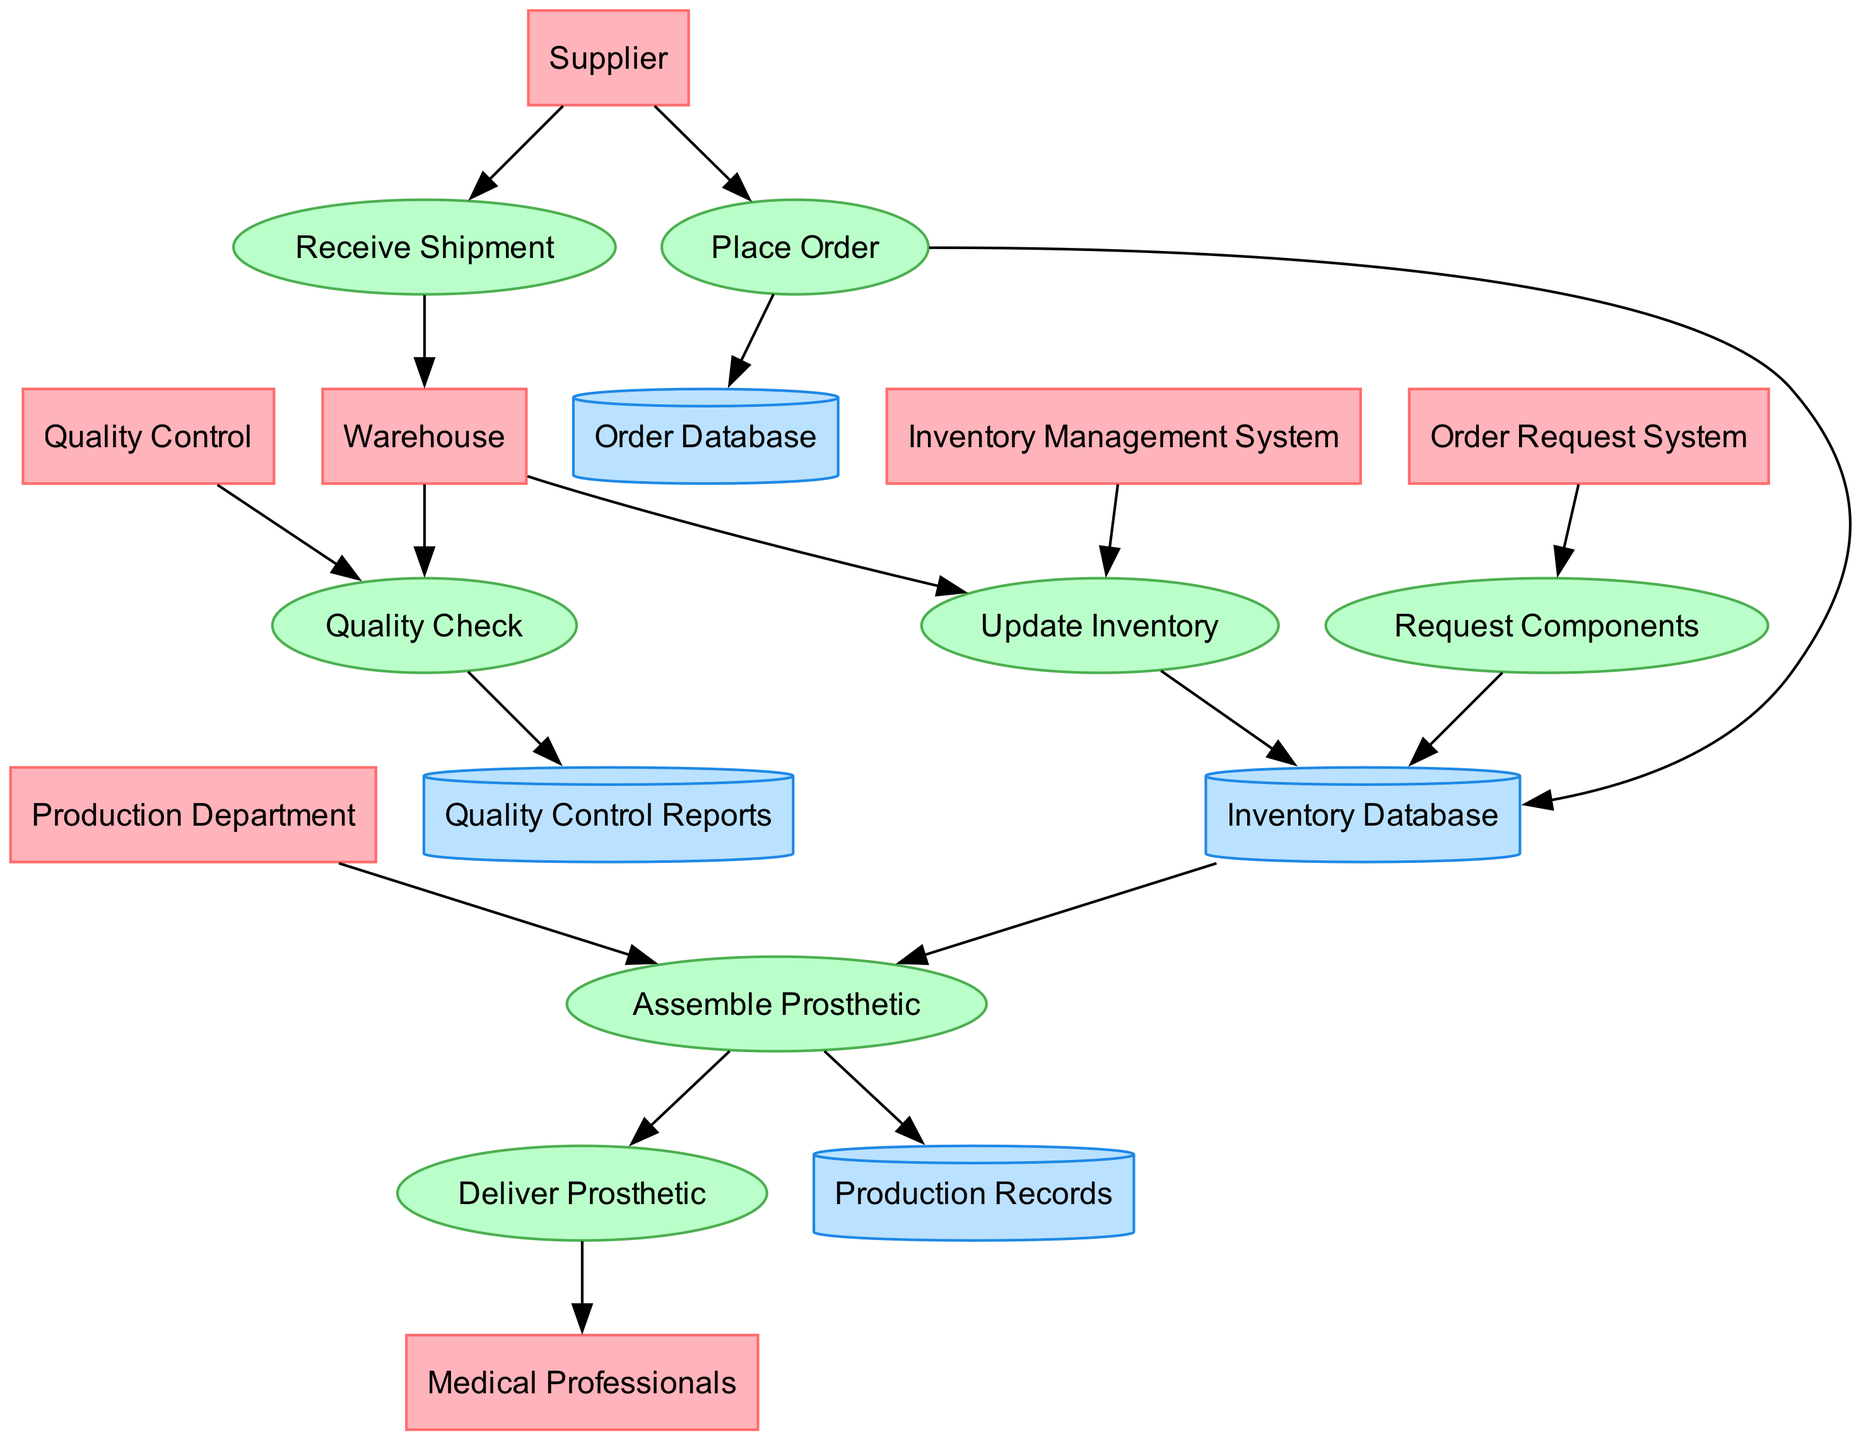What is the initial step in the inventory management process? The diagram shows that the initial step is 'Place Order', which is the process initiated in the Inventory Management System to request components from the Supplier.
Answer: Place Order Which department checks the quality of the components? The diagram indicates that the 'Quality Control' department is responsible for inspecting and verifying the components before they can be stored or used.
Answer: Quality Control How many data stores are present in the diagram? By counting the mentioned data stores, there are four distinct data stores indicated in the diagram: Inventory Database, Order Database, Quality Control Reports, and Production Records.
Answer: 4 What happens to assembled prosthetics after they are produced? The diagram clearly shows that after the prosthetics are assembled, the next step is 'Deliver Prosthetic', where the finished products are delivered to Medical Professionals.
Answer: Deliver Prosthetic Which entity is responsible for receiving shipments of new components? The 'Warehouse' is identified in the diagram as the entity that receives and logs the shipment of new components from the Supplier.
Answer: Warehouse What is updated after the 'Receive Shipment' process? According to the diagram, upon completing the 'Receive Shipment' process, the next action is 'Update Inventory' where the inventory records are revised with new quantities and locations.
Answer: Update Inventory How does the 'Order Request System' relate to the 'Inventory Database'? The relationship is depicted through the 'Request Components' process, which utilizes the Order Request System to retrieve necessary components and subsequently updates the Inventory Database.
Answer: Request Components What does the 'Quality Check' process generate? The 'Quality Check' process results in generating 'Quality Control Reports', which are stored as a repository for inspection records in the diagram.
Answer: Quality Control Reports Where do Medical Professionals receive the prosthetics? The diagram specifies that Medical Professionals receive the final assembled prosthetics after the 'Deliver Prosthetic' process is completed.
Answer: Medical Professionals 